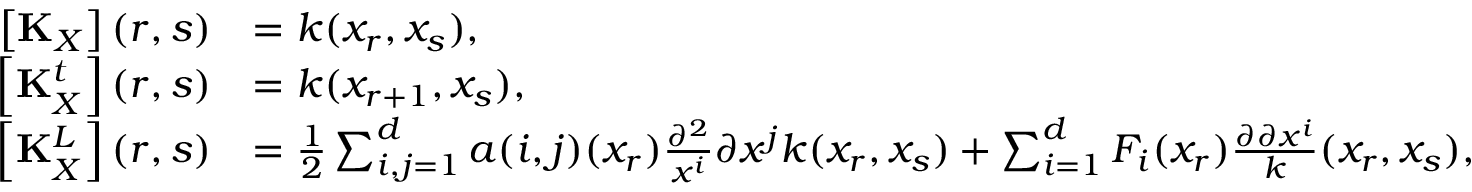Convert formula to latex. <formula><loc_0><loc_0><loc_500><loc_500>\begin{array} { r l } { \left [ K _ { X } \right ] ( r , s ) } & { = k ( x _ { r } , x _ { s } ) , } \\ { \left [ K _ { X } ^ { t } \right ] ( r , s ) } & { = k ( x _ { r + 1 } , x _ { s } ) , } \\ { \left [ K _ { X } ^ { L } \right ] ( r , s ) } & { = \frac { 1 } { 2 } \sum _ { i , j = 1 } ^ { d } a ( i , j ) ( x _ { r } ) \frac { \partial ^ { 2 } } { x ^ { i } } { \partial x ^ { j } } k ( x _ { r } , x _ { s } ) + \sum _ { i = 1 } ^ { d } F _ { i } ( x _ { r } ) \frac { \partial \partial x ^ { i } } k ( x _ { r } , x _ { s } ) , } \end{array}</formula> 